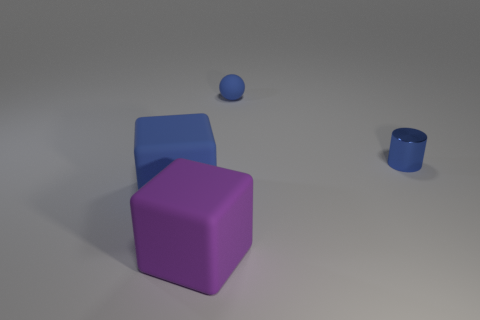How do the sizes of the objects in the image compare to each other? In the image, there are three objects of differing sizes. The purple block appears to be the largest, the blue block is medium-sized, and the smallest object is the blue sphere. 